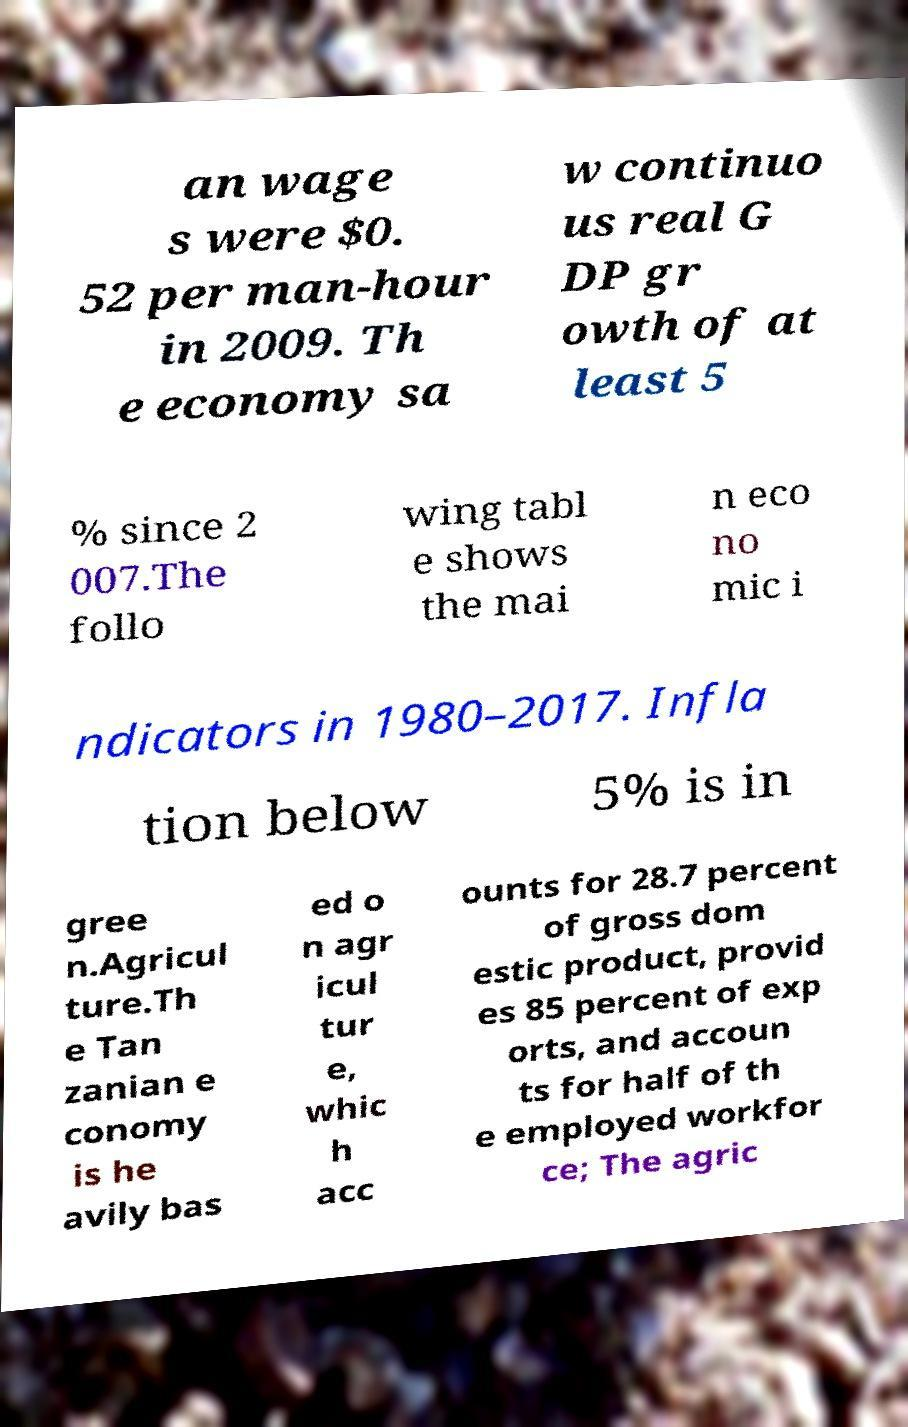Could you assist in decoding the text presented in this image and type it out clearly? an wage s were $0. 52 per man-hour in 2009. Th e economy sa w continuo us real G DP gr owth of at least 5 % since 2 007.The follo wing tabl e shows the mai n eco no mic i ndicators in 1980–2017. Infla tion below 5% is in gree n.Agricul ture.Th e Tan zanian e conomy is he avily bas ed o n agr icul tur e, whic h acc ounts for 28.7 percent of gross dom estic product, provid es 85 percent of exp orts, and accoun ts for half of th e employed workfor ce; The agric 